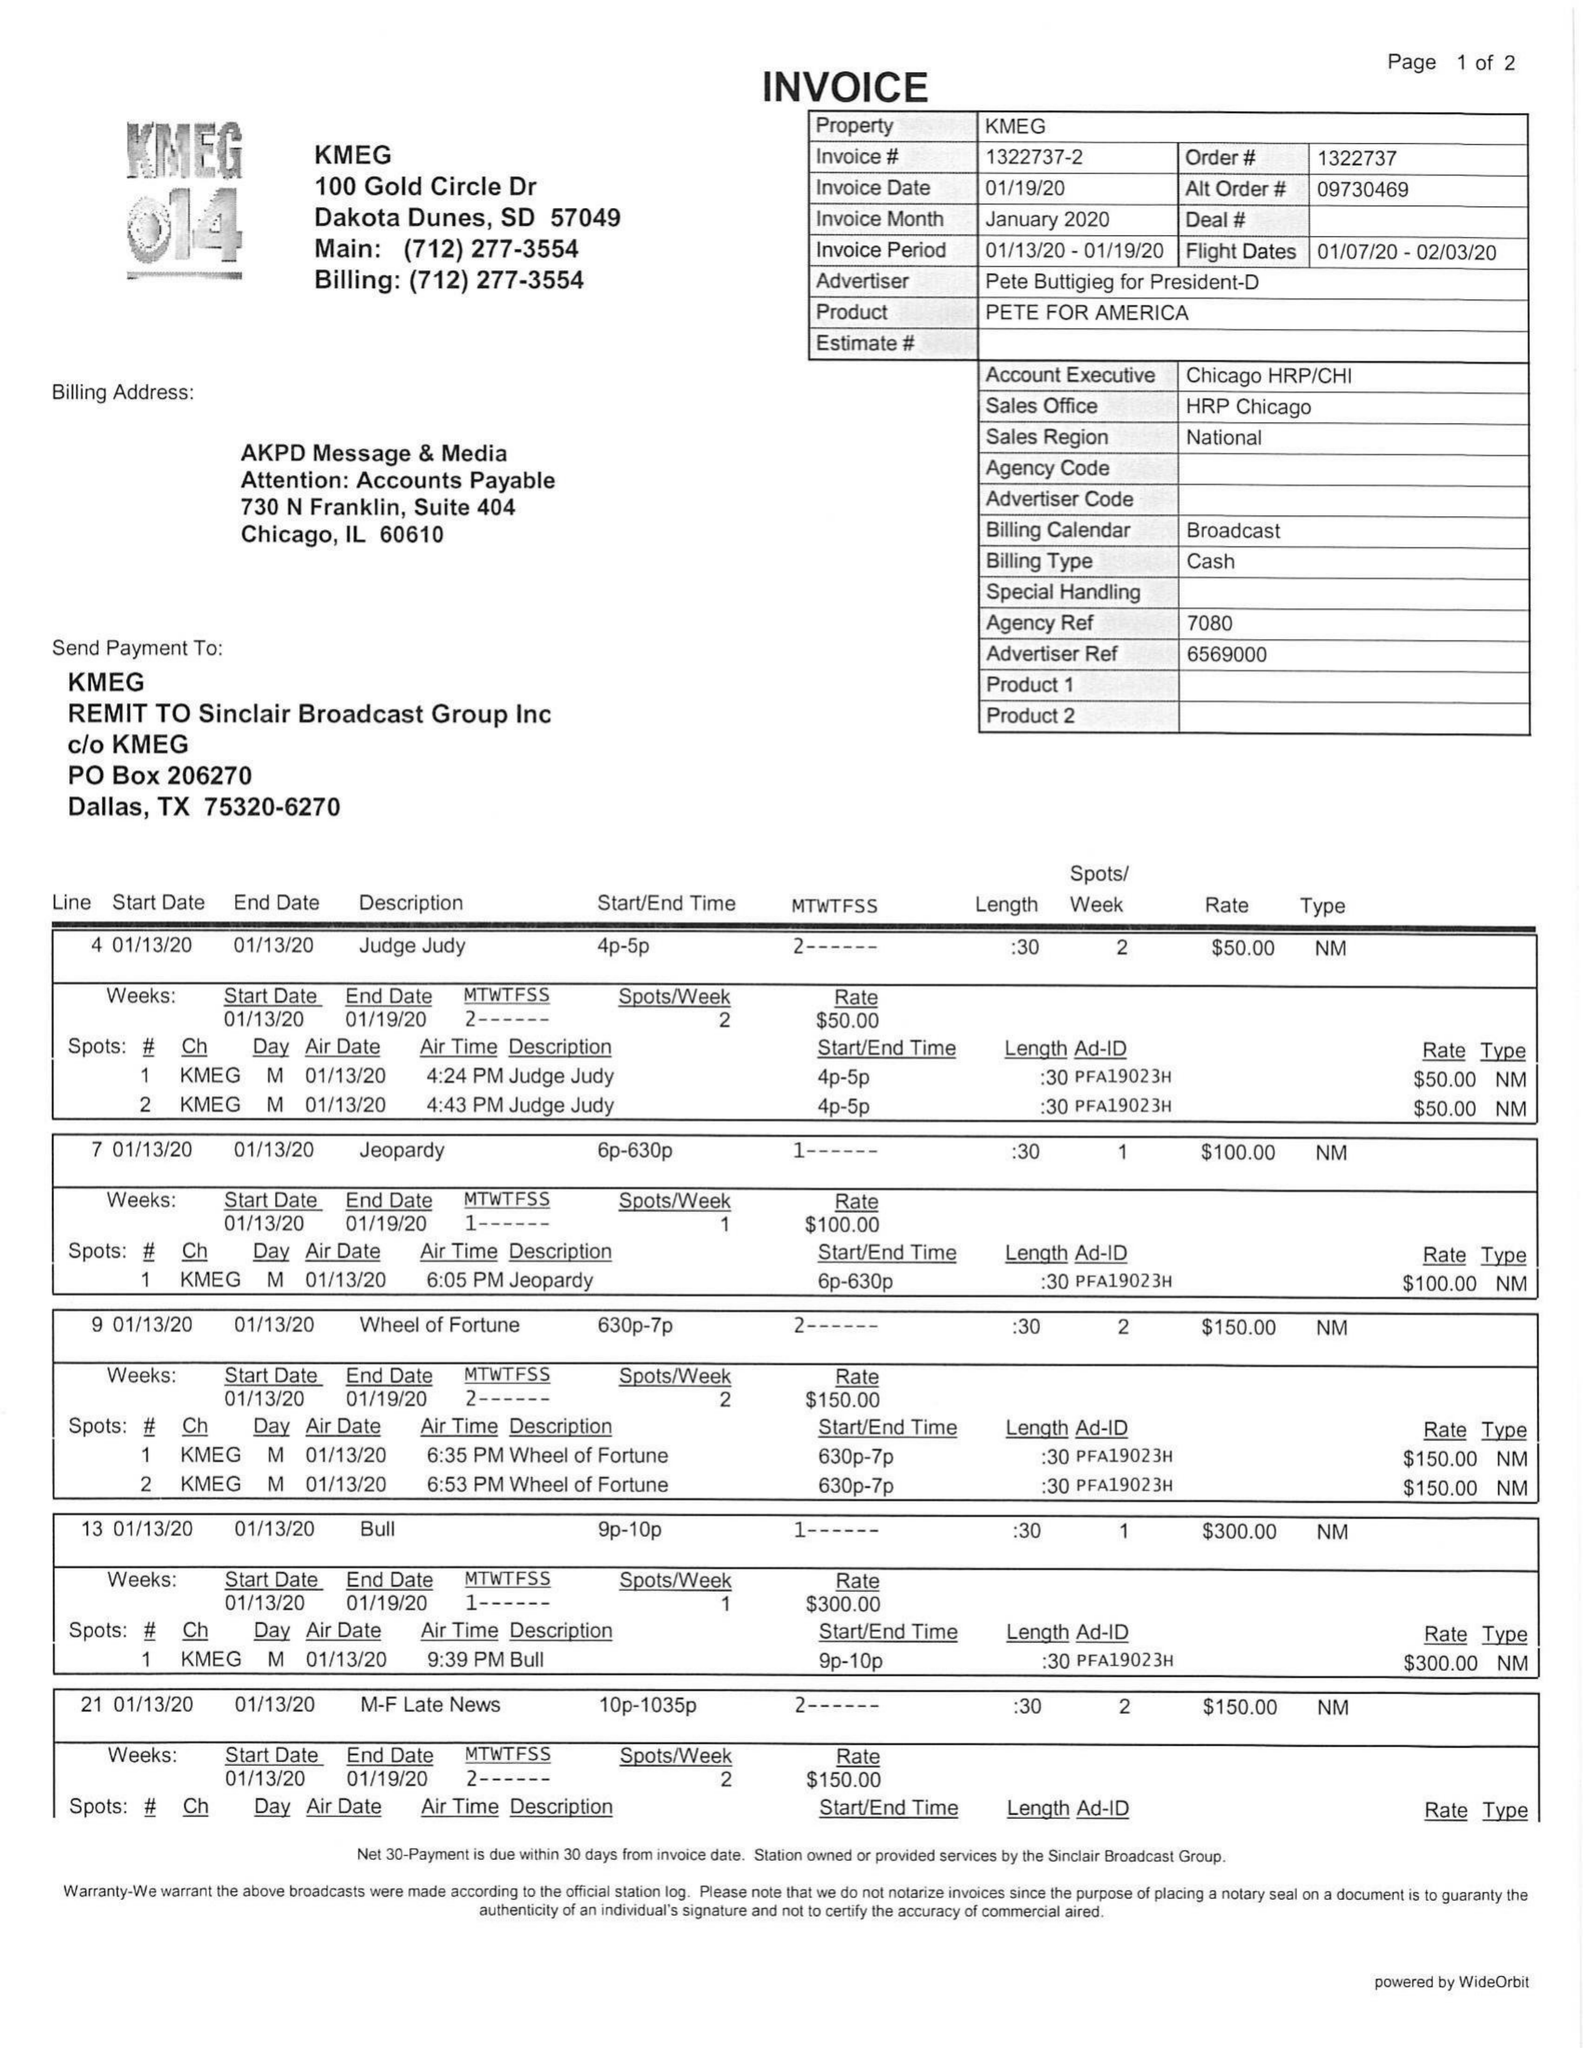What is the value for the advertiser?
Answer the question using a single word or phrase. PETE BUTTIGIEG FOR PRESIDENT-D 